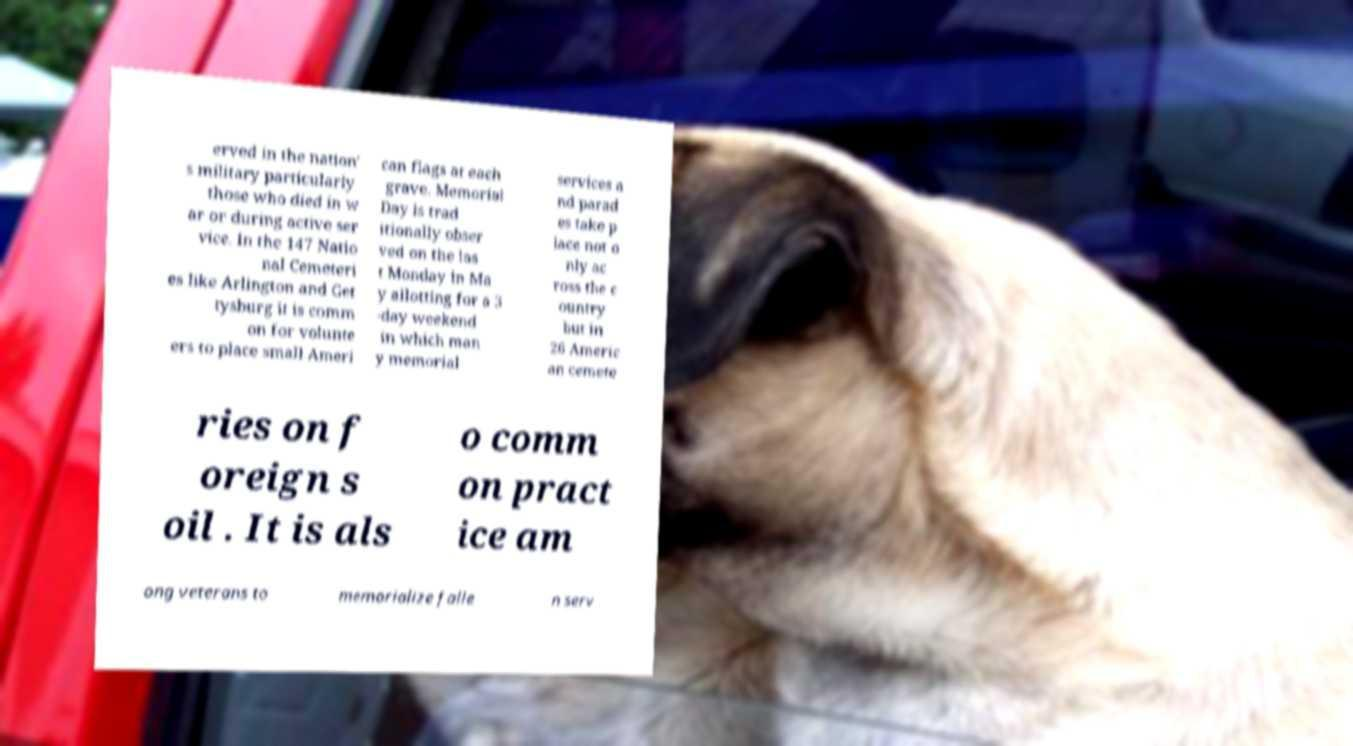What messages or text are displayed in this image? I need them in a readable, typed format. erved in the nation' s military particularly those who died in w ar or during active ser vice. In the 147 Natio nal Cemeteri es like Arlington and Get tysburg it is comm on for volunte ers to place small Ameri can flags at each grave. Memorial Day is trad itionally obser ved on the las t Monday in Ma y allotting for a 3 -day weekend in which man y memorial services a nd parad es take p lace not o nly ac ross the c ountry but in 26 Americ an cemete ries on f oreign s oil . It is als o comm on pract ice am ong veterans to memorialize falle n serv 